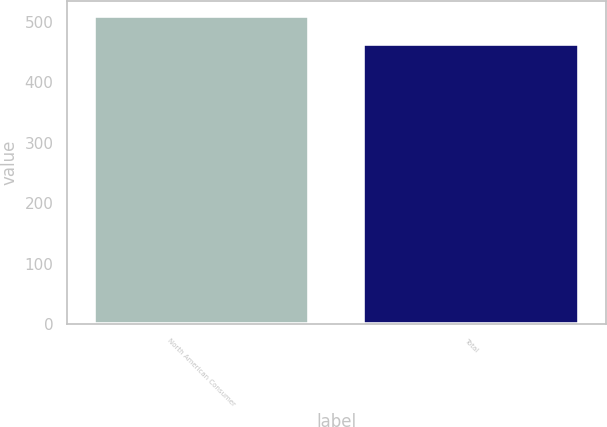Convert chart to OTSL. <chart><loc_0><loc_0><loc_500><loc_500><bar_chart><fcel>North American Consumer<fcel>Total<nl><fcel>509.3<fcel>463<nl></chart> 